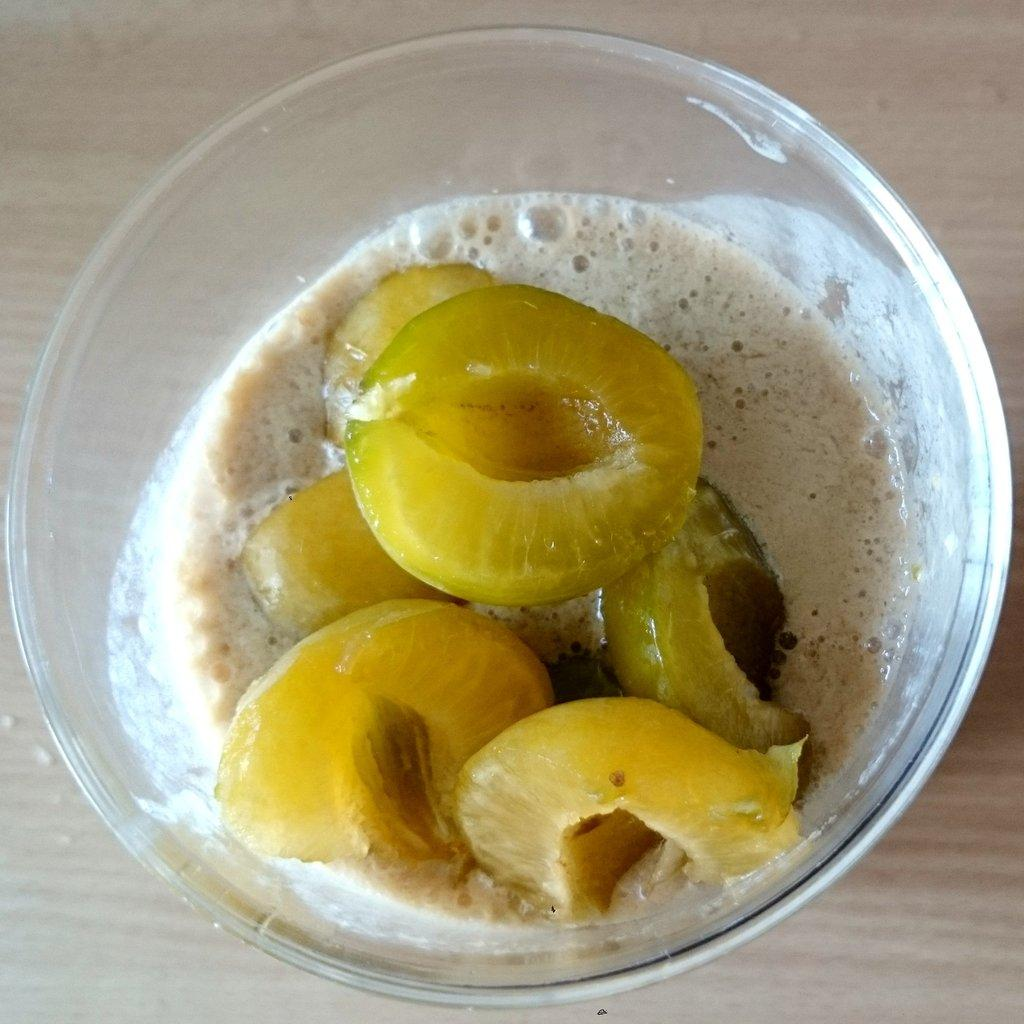What is in the bowl that is visible in the image? There is a bowl containing food in the image. Where is the bowl located in the image? The bowl is placed in the center of the image. What is the bowl resting on in the image? The bowl appears to be placed on a wooden object. What might the wooden object be in the image? The wooden object seems to be a table. How does the bowl increase in size over time in the image? The bowl does not increase in size over time in the image; it remains the same size throughout the image. 